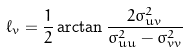<formula> <loc_0><loc_0><loc_500><loc_500>\ell _ { v } = \frac { 1 } { 2 } \arctan \frac { 2 \sigma _ { u v } ^ { 2 } } { \sigma _ { u u } ^ { 2 } - \sigma _ { v v } ^ { 2 } }</formula> 